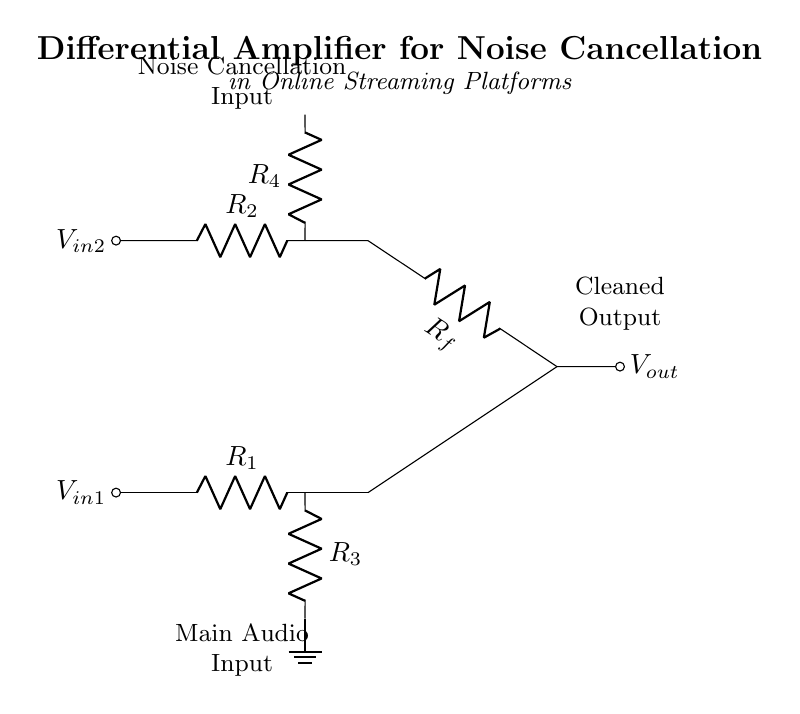What type of amplifier is depicted in the circuit? The circuit represents a differential amplifier, which amplifies the difference between two input signals and cancels out noise common to both inputs.
Answer: Differential amplifier What are the names of the input signals in the circuit? The input signals are labeled as V-in1 and V-in2, which represent the two audio inputs that the amplifier processes.
Answer: V-in1 and V-in2 How many resistors are present in the circuit? The circuit contains four resistors, named R1, R2, R3, and R4, which are used to set the gain and manage the input impedance of the amplifier.
Answer: Four resistors What is the purpose of the feedback resistor in this circuit? The feedback resistor, labeled as R-f, is used to control the gain of the amplifier and improve the circuit's performance by stabilizing its output.
Answer: Control gain How does the circuit achieve noise cancellation? The circuit achieves noise cancellation by taking the difference between the two input signals, effectively canceling out any noise that is common to both inputs. This is the main function of a differential amplifier.
Answer: By subtracting common noise from input signals What is fed back to the input of the op-amp? The output voltage, labeled V-out, is fed back to the non-inverting input of the op-amp, which allows for the necessary feedback to set the amplifier's gain.
Answer: V-out 